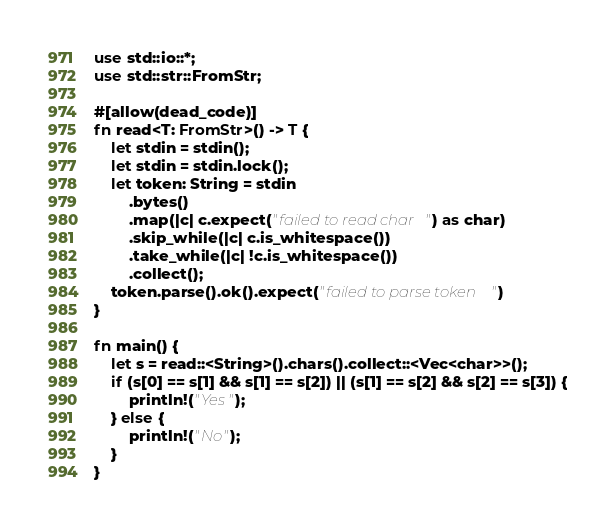<code> <loc_0><loc_0><loc_500><loc_500><_Rust_>use std::io::*;
use std::str::FromStr;

#[allow(dead_code)]
fn read<T: FromStr>() -> T {
    let stdin = stdin();
    let stdin = stdin.lock();
    let token: String = stdin
        .bytes()
        .map(|c| c.expect("failed to read char") as char)
        .skip_while(|c| c.is_whitespace())
        .take_while(|c| !c.is_whitespace())
        .collect();
    token.parse().ok().expect("failed to parse token")
}

fn main() {
    let s = read::<String>().chars().collect::<Vec<char>>();
    if (s[0] == s[1] && s[1] == s[2]) || (s[1] == s[2] && s[2] == s[3]) {
        println!("Yes");
    } else {
        println!("No");
    }
}
</code> 